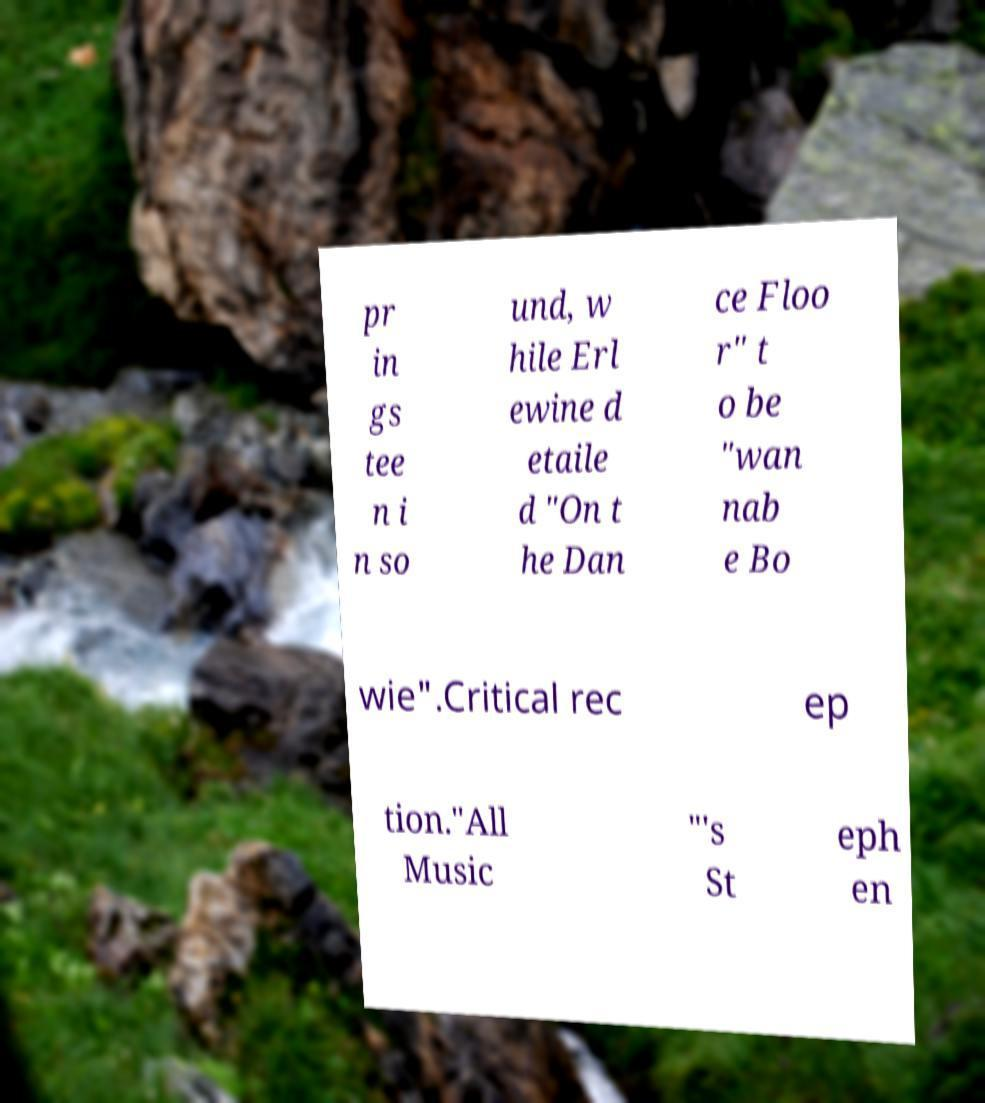I need the written content from this picture converted into text. Can you do that? pr in gs tee n i n so und, w hile Erl ewine d etaile d "On t he Dan ce Floo r" t o be "wan nab e Bo wie".Critical rec ep tion."All Music "'s St eph en 